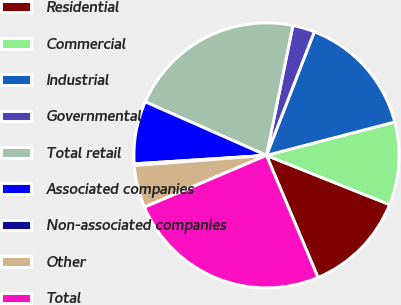Convert chart. <chart><loc_0><loc_0><loc_500><loc_500><pie_chart><fcel>Residential<fcel>Commercial<fcel>Industrial<fcel>Governmental<fcel>Total retail<fcel>Associated companies<fcel>Non-associated companies<fcel>Other<fcel>Total<nl><fcel>12.59%<fcel>10.11%<fcel>15.07%<fcel>2.68%<fcel>21.57%<fcel>7.64%<fcel>0.21%<fcel>5.16%<fcel>24.97%<nl></chart> 